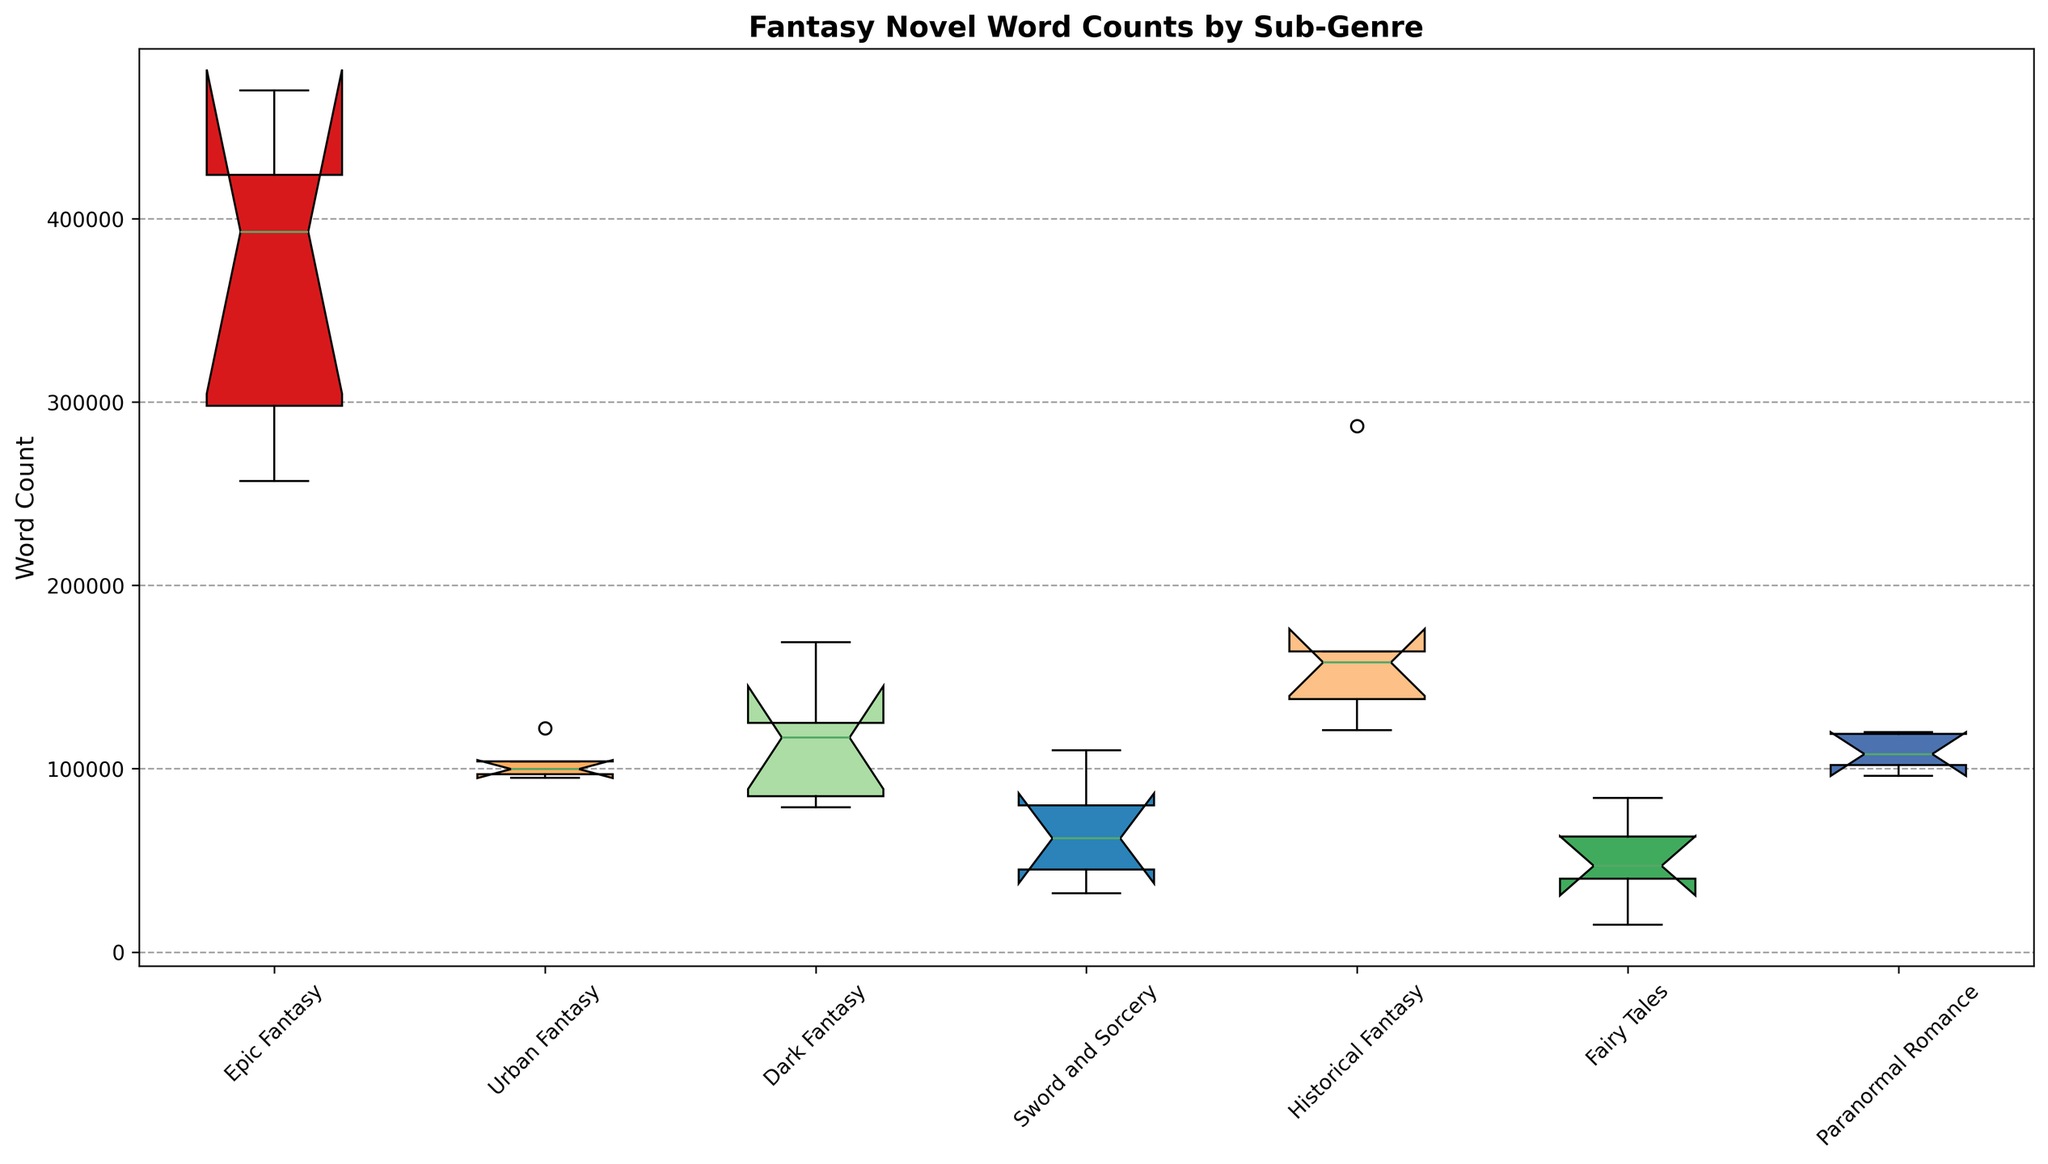Which sub-genre has the highest median word count? By visually inspecting the box plot, look for the sub-genre with the median line (horizontal line inside the box) placed at the highest value on the y-axis.
Answer: Epic Fantasy Which sub-genre has the lowest median word count? By visually inspecting the box plot, look for the sub-genre with the median line placed at the lowest value on the y-axis.
Answer: Sword and Sorcery What is the range of word counts for Urban Fantasy? The range is defined by the distance between the minimum (bottom whisker) and the maximum (top whisker) word counts. Look at the lowest and highest points of the whiskers for Urban Fantasy.
Answer: 95000 - 122000 Which sub-genre shows the most variability in word counts? Look for the sub-genre with the largest distance between the top and bottom whiskers, which indicates the range of data.
Answer: Epic Fantasy Compare the median word counts between Epic Fantasy and Dark Fantasy. Which one is higher? Visually compare the positions of the median lines of Epic Fantasy and Dark Fantasy.
Answer: Epic Fantasy Which sub-genre has a median word count closest to 100,000 words? Look for the median lines closest to the 100,000-word mark on the y-axis.
Answer: Urban Fantasy What is the interquartile range (IQR) of word counts for Sword and Sorcery? The IQR is the distance between the first quartile (bottom edge of the box) and the third quartile (top edge of the box). Inspect the positions of these edges for Sword and Sorcery.
Answer: 32000 - 80000 Are there any outliers visible in the box plot? If yes, which sub-genre(s) show outliers? Outliers are marked by points outside the whiskers. Check if there are any such points and identify the corresponding sub-genres.
Answer: No Between Historical Fantasy and Paranormal Romance, which sub-genre has a wider spread of word counts? Compare the distance between the whiskers for both Historical Fantasy and Paranormal Romance. The sub-genre with the wider spread will have a larger range.
Answer: Historical Fantasy Which sub-genre has the smallest range of word counts? Look for the sub-genre with the shortest distance between the top and bottom whiskers, indicating the smallest range of word counts.
Answer: Paranormal Romance 